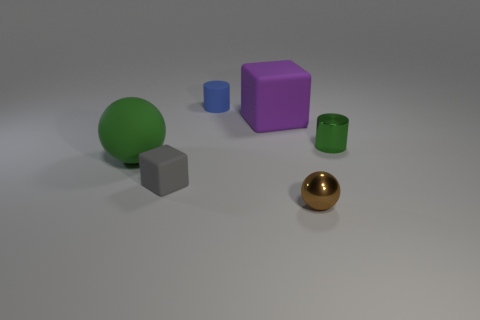There is a rubber object that is the same color as the metal cylinder; what shape is it?
Give a very brief answer. Sphere. How big is the green ball?
Provide a succinct answer. Large. Are there an equal number of brown metal balls that are left of the big sphere and purple cylinders?
Offer a very short reply. Yes. Is the size of the gray matte block the same as the ball to the left of the big purple rubber cube?
Your response must be concise. No. How many tiny green cylinders have the same material as the purple block?
Give a very brief answer. 0. Is the purple rubber thing the same size as the green sphere?
Your answer should be compact. Yes. Are there any other things of the same color as the matte ball?
Your answer should be very brief. Yes. The small object that is both behind the gray matte object and on the right side of the blue cylinder has what shape?
Your response must be concise. Cylinder. There is a metal object that is in front of the green cylinder; what is its size?
Your response must be concise. Small. What number of small gray matte blocks are in front of the cube in front of the cube behind the green metallic thing?
Your response must be concise. 0. 